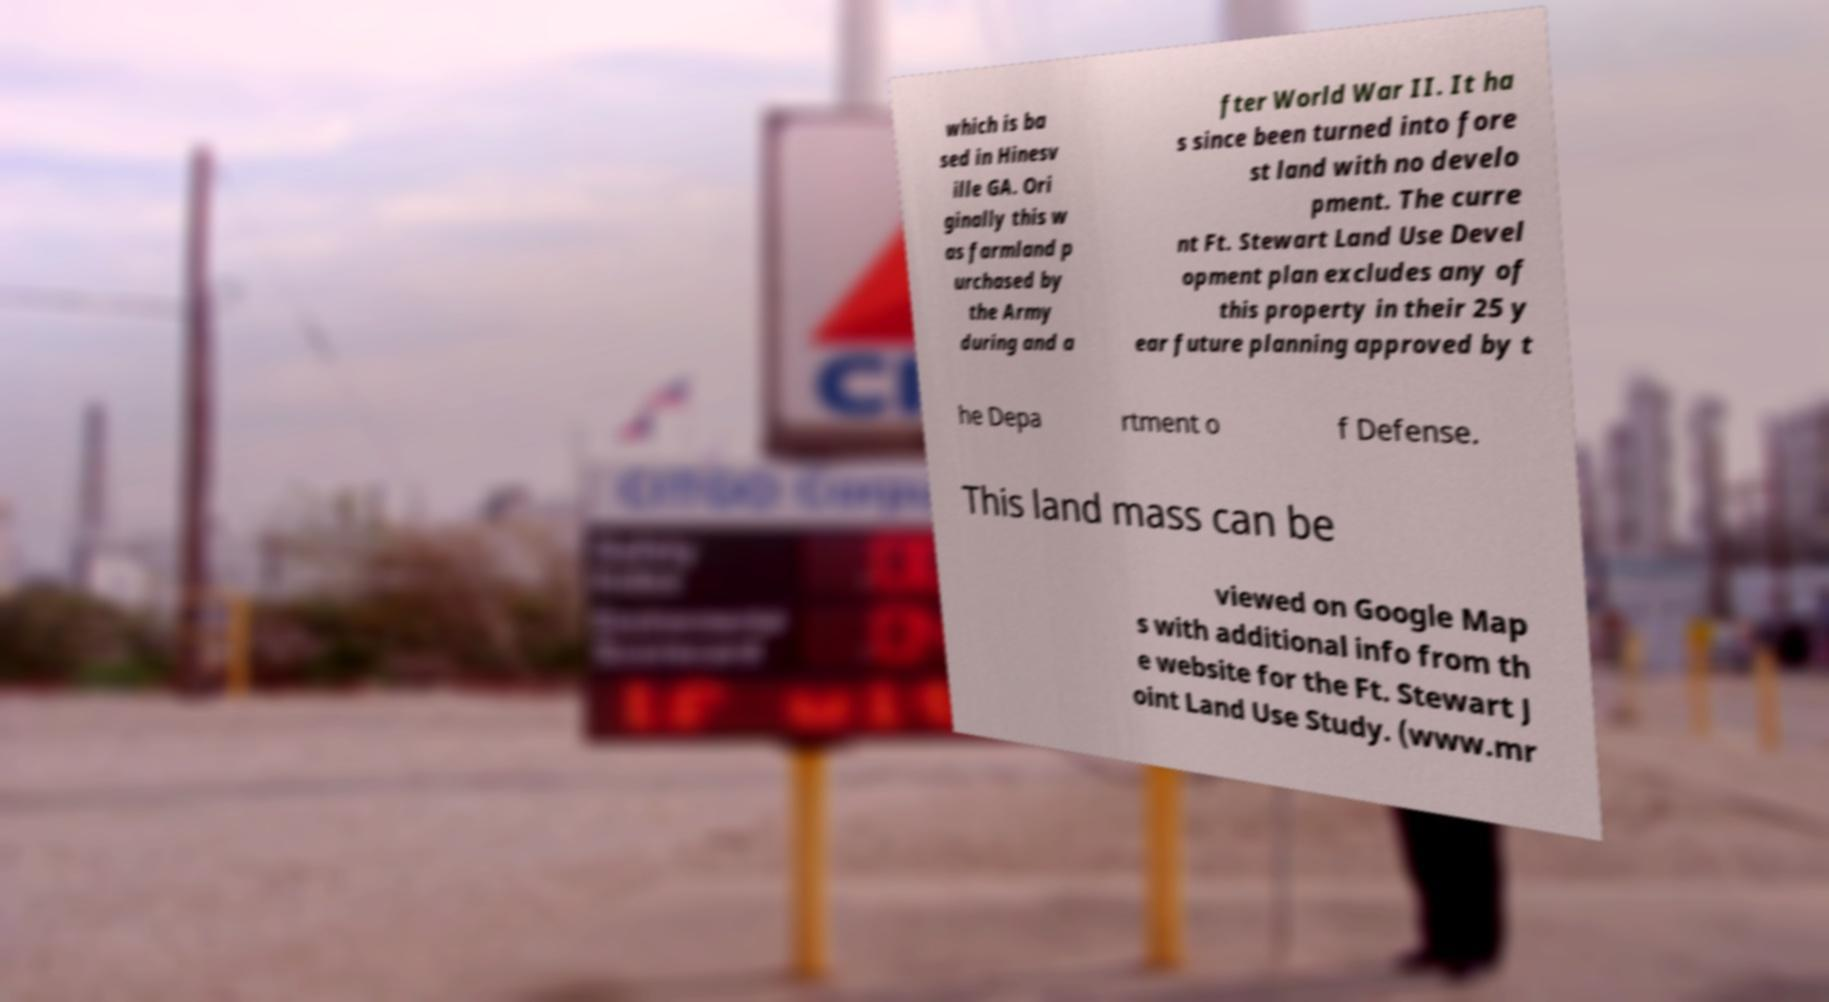Can you read and provide the text displayed in the image?This photo seems to have some interesting text. Can you extract and type it out for me? which is ba sed in Hinesv ille GA. Ori ginally this w as farmland p urchased by the Army during and a fter World War II. It ha s since been turned into fore st land with no develo pment. The curre nt Ft. Stewart Land Use Devel opment plan excludes any of this property in their 25 y ear future planning approved by t he Depa rtment o f Defense. This land mass can be viewed on Google Map s with additional info from th e website for the Ft. Stewart J oint Land Use Study. (www.mr 